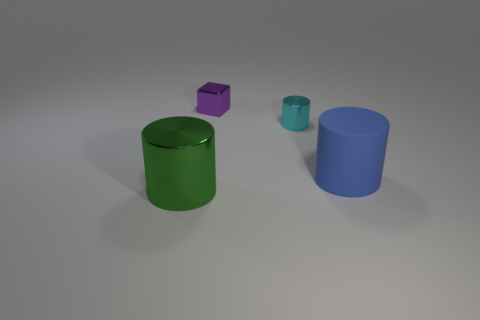Subtract all large blue matte cylinders. How many cylinders are left? 2 Add 4 small purple metal things. How many objects exist? 8 Subtract all cyan cylinders. How many cylinders are left? 2 Subtract 1 cylinders. How many cylinders are left? 2 Subtract all blocks. How many objects are left? 3 Add 3 rubber objects. How many rubber objects are left? 4 Add 1 gray metal cubes. How many gray metal cubes exist? 1 Subtract 1 green cylinders. How many objects are left? 3 Subtract all gray cubes. Subtract all purple balls. How many cubes are left? 1 Subtract all rubber cylinders. Subtract all big yellow cylinders. How many objects are left? 3 